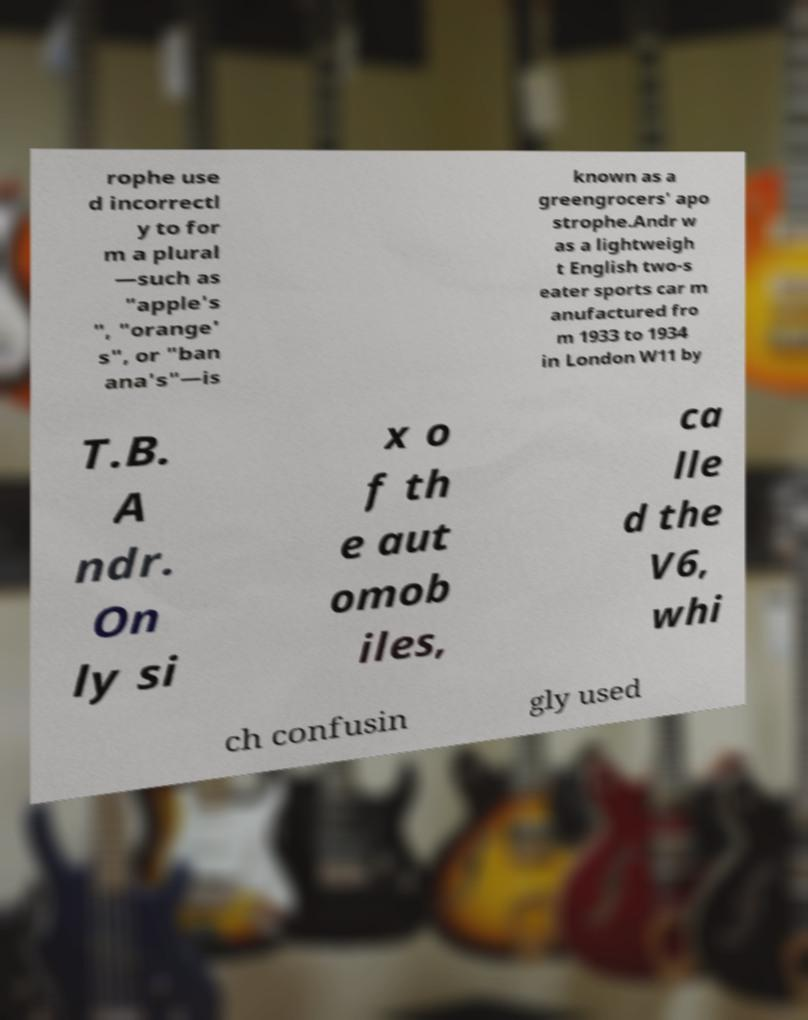Could you extract and type out the text from this image? rophe use d incorrectl y to for m a plural —such as "apple's ", "orange' s", or "ban ana's"—is known as a greengrocers' apo strophe.Andr w as a lightweigh t English two-s eater sports car m anufactured fro m 1933 to 1934 in London W11 by T.B. A ndr. On ly si x o f th e aut omob iles, ca lle d the V6, whi ch confusin gly used 